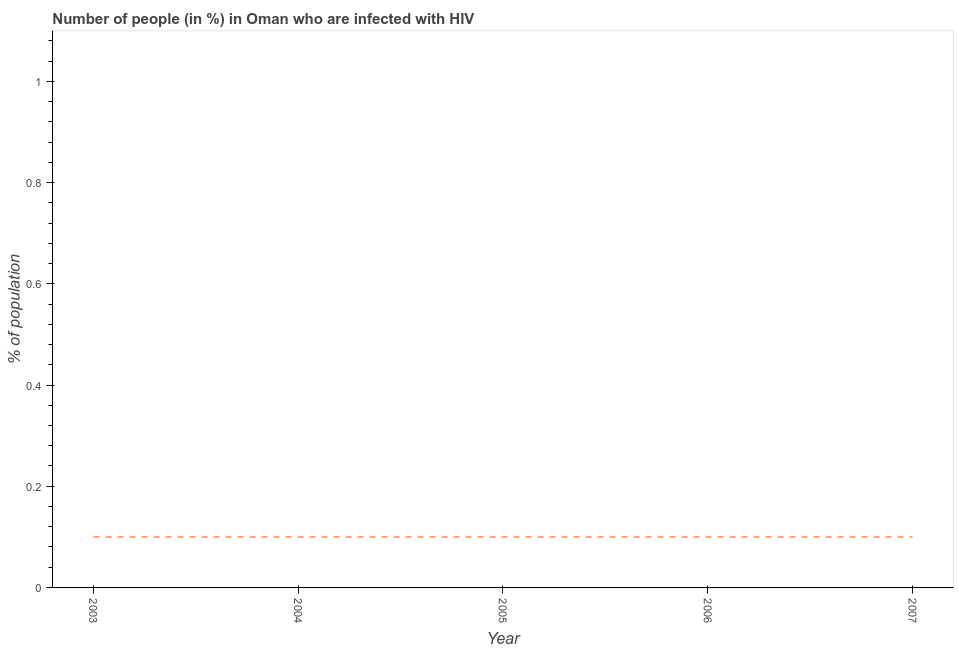Across all years, what is the maximum number of people infected with hiv?
Ensure brevity in your answer.  0.1. What is the sum of the number of people infected with hiv?
Make the answer very short. 0.5. In how many years, is the number of people infected with hiv greater than 0.44 %?
Your answer should be compact. 0. What is the ratio of the number of people infected with hiv in 2004 to that in 2005?
Make the answer very short. 1. Does the number of people infected with hiv monotonically increase over the years?
Your answer should be compact. No. How many lines are there?
Give a very brief answer. 1. Are the values on the major ticks of Y-axis written in scientific E-notation?
Provide a short and direct response. No. Does the graph contain any zero values?
Provide a succinct answer. No. What is the title of the graph?
Your response must be concise. Number of people (in %) in Oman who are infected with HIV. What is the label or title of the Y-axis?
Provide a succinct answer. % of population. What is the % of population in 2005?
Give a very brief answer. 0.1. What is the difference between the % of population in 2003 and 2004?
Ensure brevity in your answer.  0. What is the difference between the % of population in 2003 and 2005?
Make the answer very short. 0. What is the difference between the % of population in 2003 and 2006?
Provide a succinct answer. 0. What is the difference between the % of population in 2005 and 2006?
Keep it short and to the point. 0. What is the ratio of the % of population in 2003 to that in 2004?
Your response must be concise. 1. What is the ratio of the % of population in 2003 to that in 2007?
Provide a short and direct response. 1. What is the ratio of the % of population in 2005 to that in 2006?
Your response must be concise. 1. 